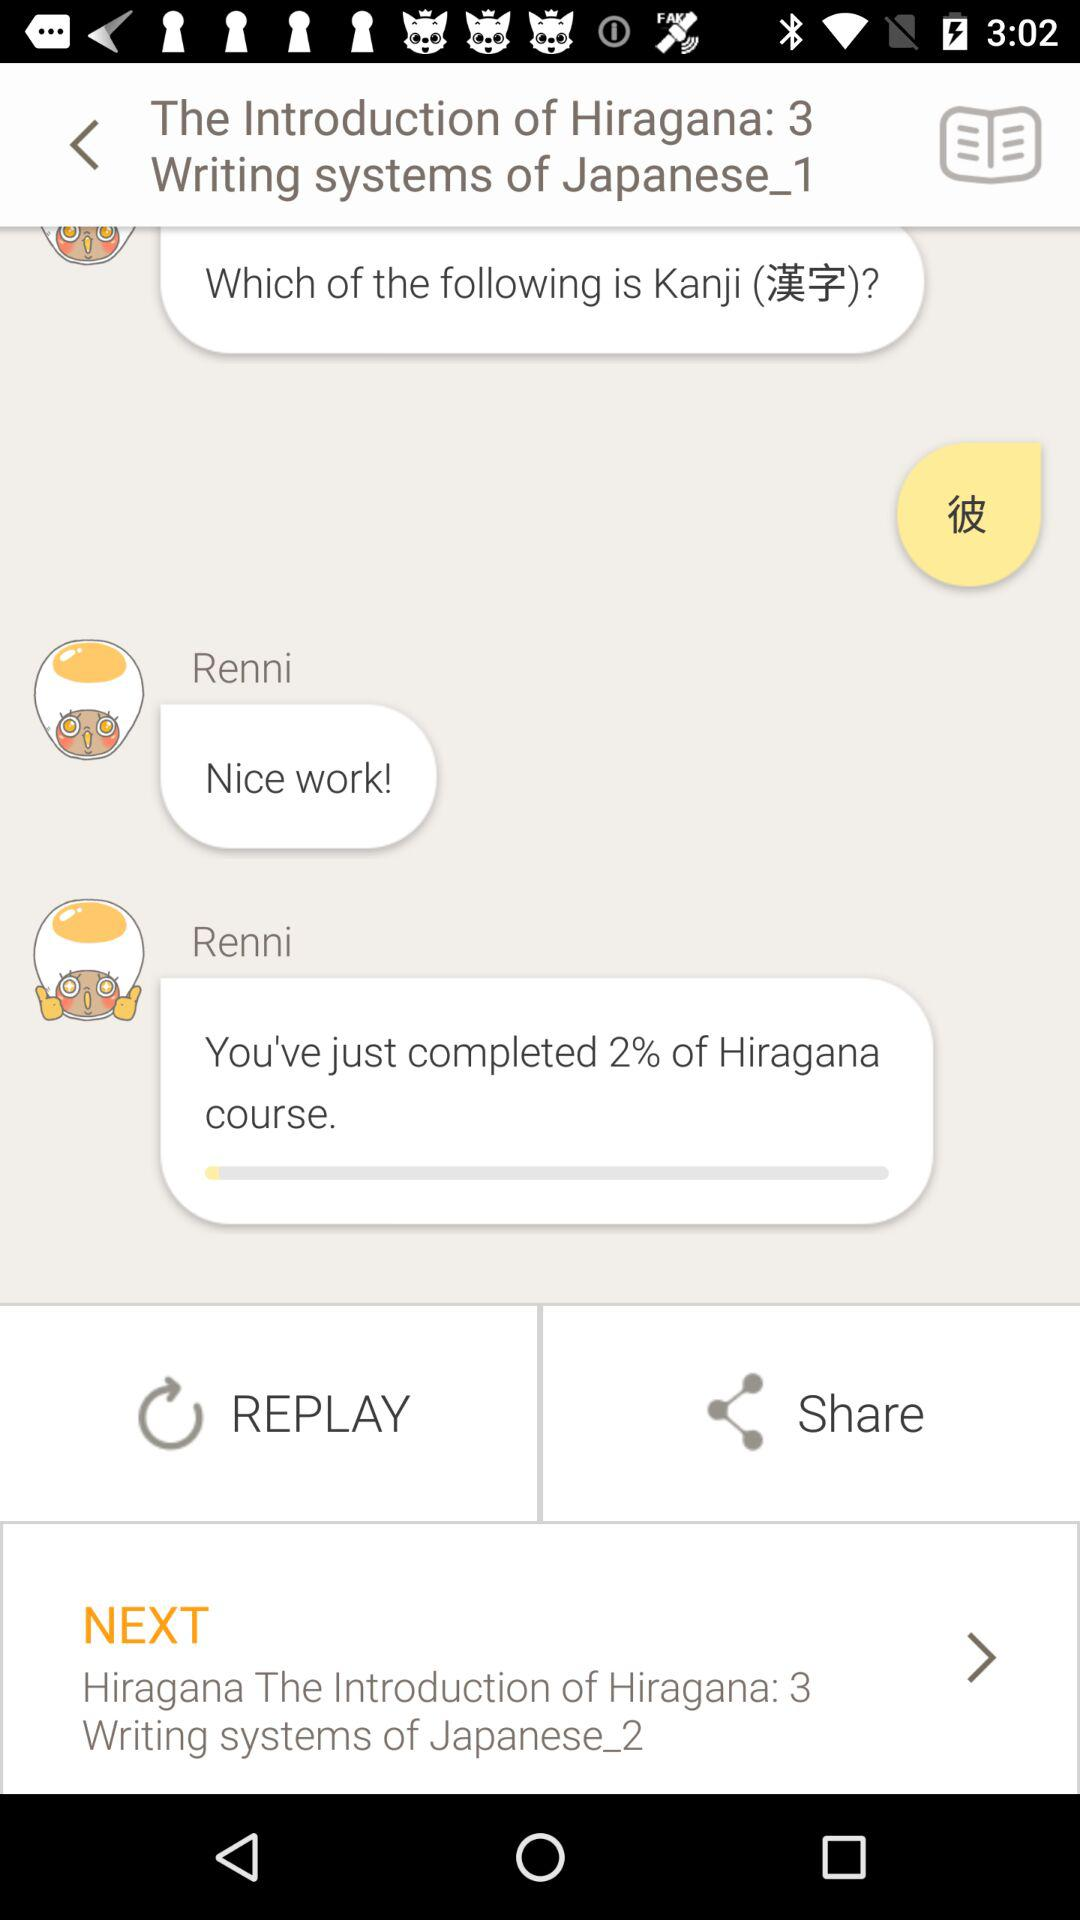What is the name of the course? The name of the course is "The Introduction of Hiragana: 3". 